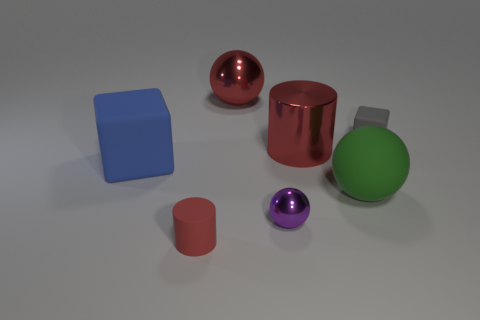Add 1 metallic cylinders. How many objects exist? 8 Subtract all large spheres. How many spheres are left? 1 Subtract all gray cubes. How many cubes are left? 1 Subtract all cubes. How many objects are left? 5 Subtract 2 spheres. How many spheres are left? 1 Subtract 0 cyan cylinders. How many objects are left? 7 Subtract all gray cylinders. Subtract all brown balls. How many cylinders are left? 2 Subtract all small gray metallic cubes. Subtract all small objects. How many objects are left? 4 Add 5 big balls. How many big balls are left? 7 Add 7 gray matte things. How many gray matte things exist? 8 